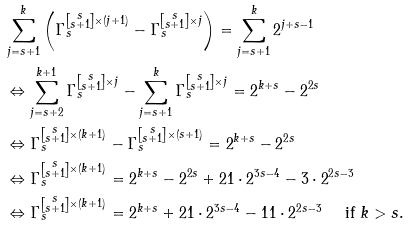<formula> <loc_0><loc_0><loc_500><loc_500>& \sum _ { j = s + 1 } ^ { k } \left ( \Gamma _ { s } ^ { \left [ \substack { s \\ s + 1 } \right ] \times ( j + 1 ) } - \Gamma _ { s } ^ { \left [ \substack { s \\ s + 1 } \right ] \times j } \right ) = \sum _ { j = s + 1 } ^ { k } 2 ^ { j + s - 1 } \\ & \Leftrightarrow \sum _ { j = s + 2 } ^ { k + 1 } \Gamma _ { s } ^ { \left [ \substack { s \\ s + 1 } \right ] \times j } - \sum _ { j = s + 1 } ^ { k } \Gamma _ { s } ^ { \left [ \substack { s \\ s + 1 } \right ] \times j } = 2 ^ { k + s } - 2 ^ { 2 s } \\ & \Leftrightarrow \Gamma _ { s } ^ { \left [ \substack { s \\ s + 1 } \right ] \times ( k + 1 ) } - \Gamma _ { s } ^ { \left [ \substack { s \\ s + 1 } \right ] \times ( s + 1 ) } = 2 ^ { k + s } - 2 ^ { 2 s } \\ & \Leftrightarrow \Gamma _ { s } ^ { \left [ \substack { s \\ s + 1 } \right ] \times ( k + 1 ) } = 2 ^ { k + s } - 2 ^ { 2 s } + 2 1 \cdot 2 ^ { 3 s - 4 } - 3 \cdot 2 ^ { 2 s - 3 } \\ & \Leftrightarrow \Gamma _ { s } ^ { \left [ \substack { s \\ s + 1 } \right ] \times ( k + 1 ) } = 2 ^ { k + s } + 2 1 \cdot 2 ^ { 3 s - 4 } - 1 1 \cdot 2 ^ { 2 s - 3 } \quad \text { if $ k > s $} . \\ &</formula> 